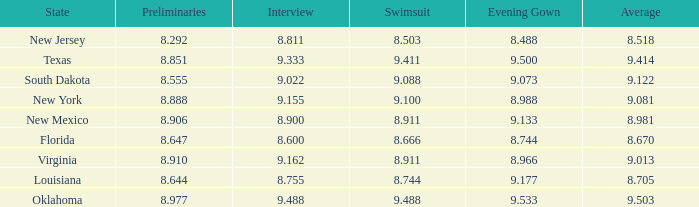 what's the preliminaries where state is south dakota 8.555. 